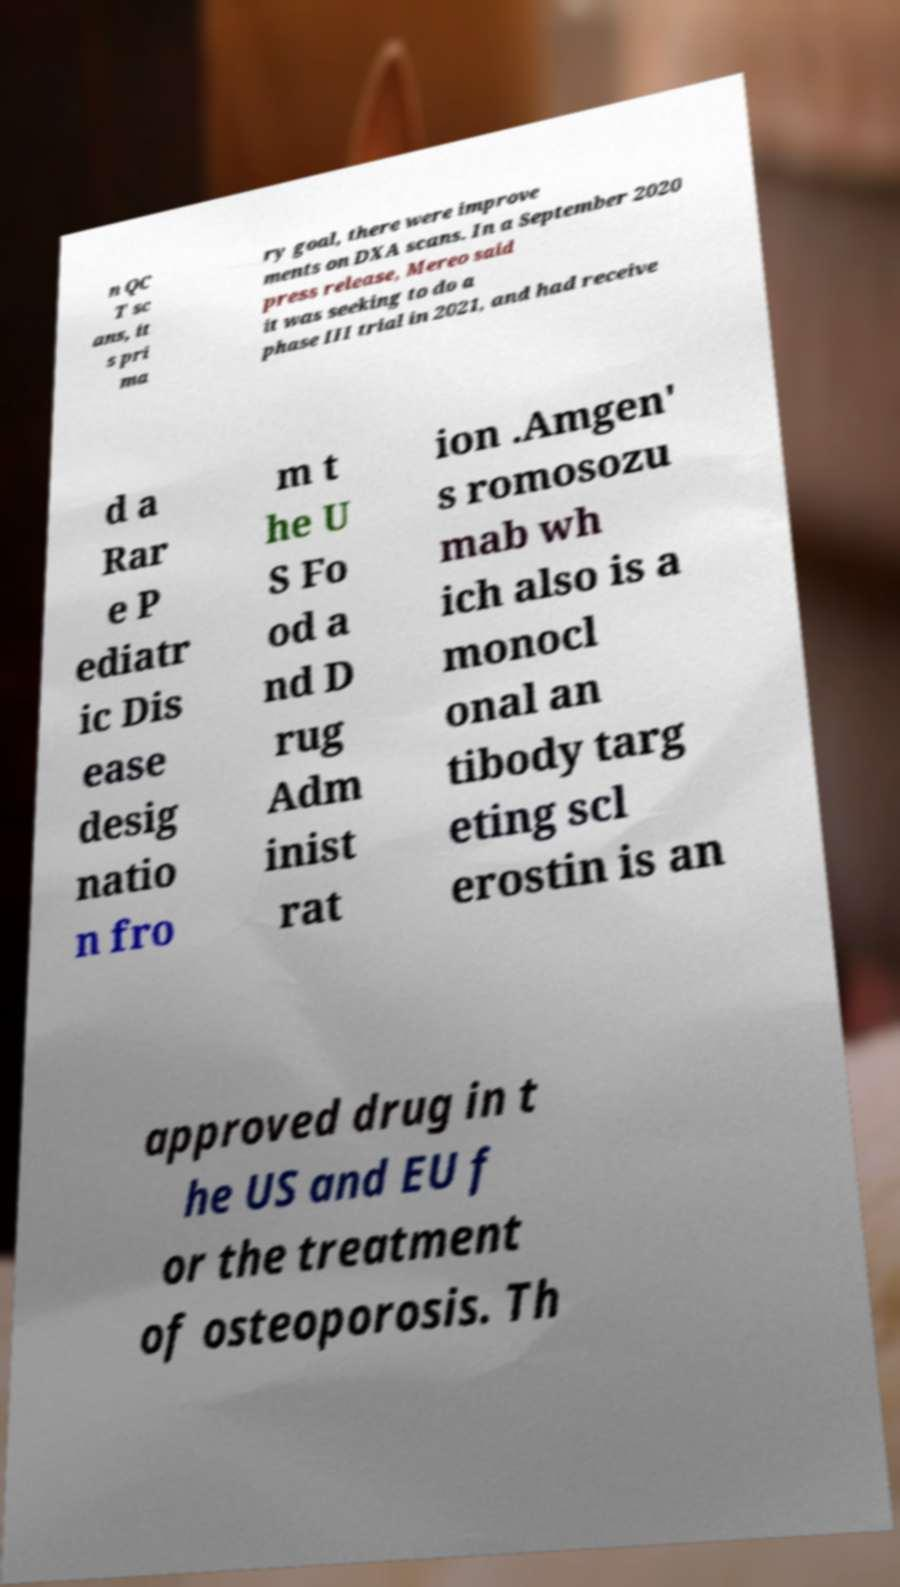For documentation purposes, I need the text within this image transcribed. Could you provide that? n QC T sc ans, it s pri ma ry goal, there were improve ments on DXA scans. In a September 2020 press release, Mereo said it was seeking to do a phase III trial in 2021, and had receive d a Rar e P ediatr ic Dis ease desig natio n fro m t he U S Fo od a nd D rug Adm inist rat ion .Amgen' s romosozu mab wh ich also is a monocl onal an tibody targ eting scl erostin is an approved drug in t he US and EU f or the treatment of osteoporosis. Th 